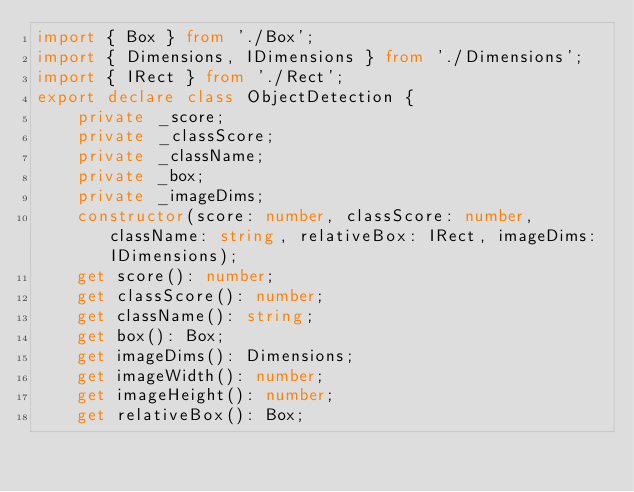<code> <loc_0><loc_0><loc_500><loc_500><_TypeScript_>import { Box } from './Box';
import { Dimensions, IDimensions } from './Dimensions';
import { IRect } from './Rect';
export declare class ObjectDetection {
    private _score;
    private _classScore;
    private _className;
    private _box;
    private _imageDims;
    constructor(score: number, classScore: number, className: string, relativeBox: IRect, imageDims: IDimensions);
    get score(): number;
    get classScore(): number;
    get className(): string;
    get box(): Box;
    get imageDims(): Dimensions;
    get imageWidth(): number;
    get imageHeight(): number;
    get relativeBox(): Box;</code> 